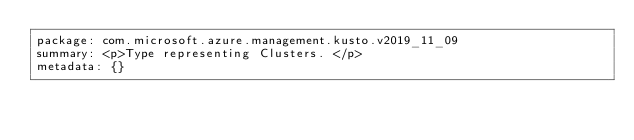Convert code to text. <code><loc_0><loc_0><loc_500><loc_500><_YAML_>package: com.microsoft.azure.management.kusto.v2019_11_09
summary: <p>Type representing Clusters. </p>
metadata: {}
</code> 